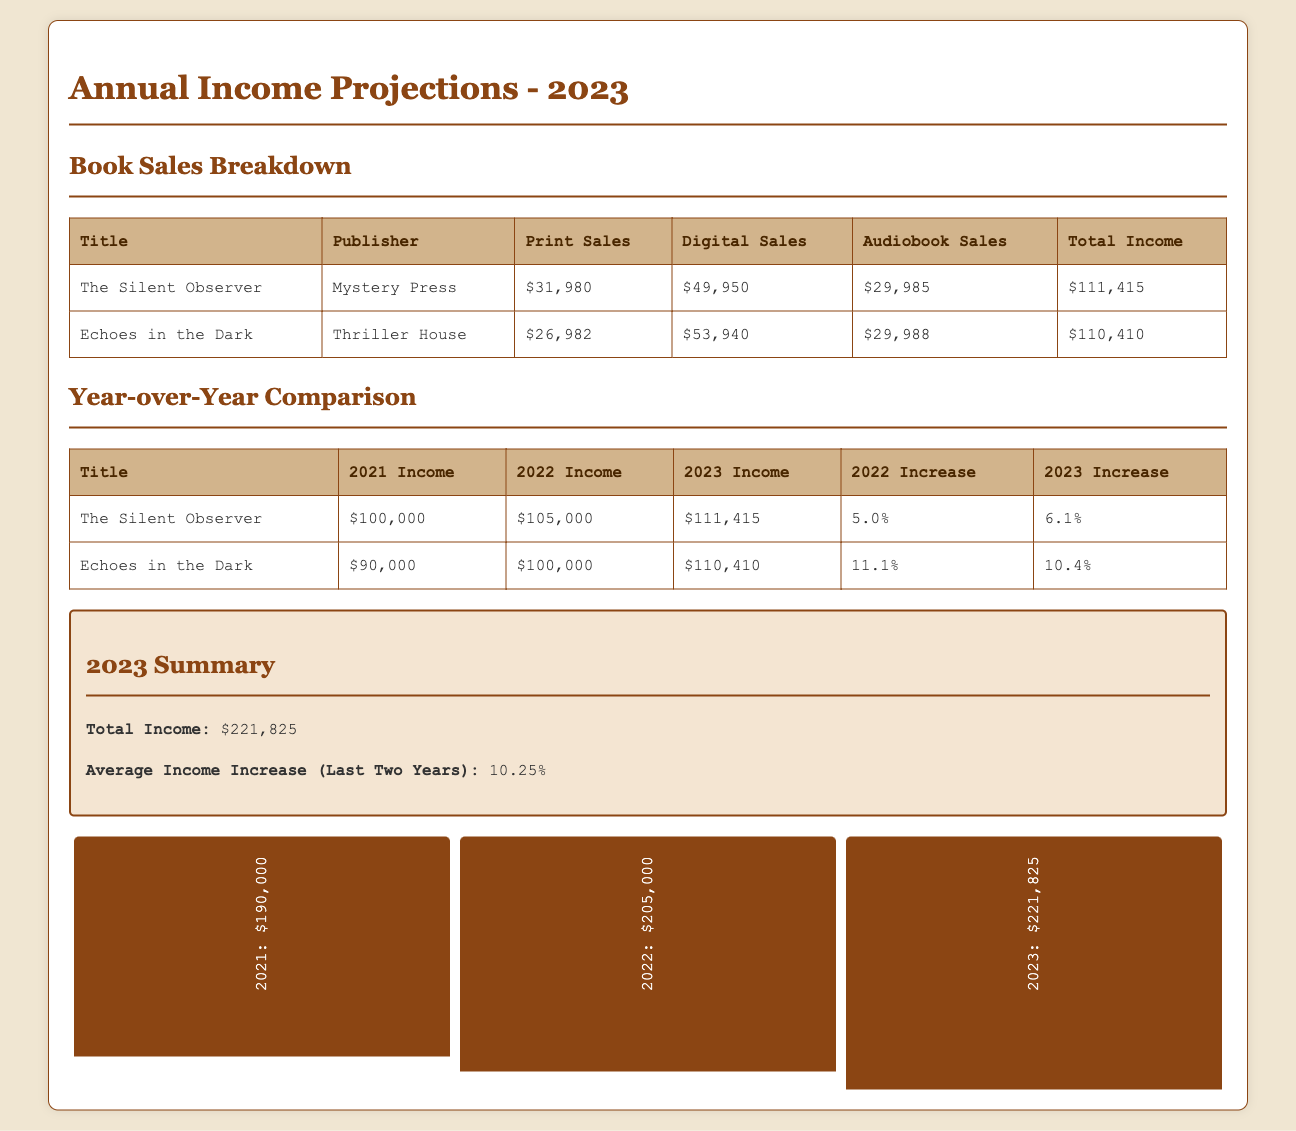What is the total income for The Silent Observer? The total income is listed directly in the document under the relevant title, which is $111,415.
Answer: $111,415 What publisher is associated with Echoes in the Dark? The document specifies the publisher for each title, with Echoes in the Dark published by Thriller House.
Answer: Thriller House What was the income increase percentage for The Silent Observer from 2022 to 2023? The document shows the increase percentage from 2022 to 2023 for The Silent Observer as 6.1%.
Answer: 6.1% What is the total income for 2023? The total income is provided in the summary section of the document, summing all titles to give $221,825.
Answer: $221,825 Which sales channel had the highest income for Echoes in the Dark? The document lists sales incomes by channel, showing digital sales at $53,940 as the highest for Echoes in the Dark.
Answer: Digital Sales What was the income for Echoes in the Dark in 2021? The historical income for each title is specified, with Echoes in the Dark earning $90,000 in 2021.
Answer: $90,000 What was the average income increase over the last two years? The document calculates and states the average increase percentage clearly, which is 10.25%.
Answer: 10.25% What is the total income from audiobook sales for The Silent Observer? The report breaks down the sales by format, and the audiobook income for The Silent Observer is $29,985.
Answer: $29,985 